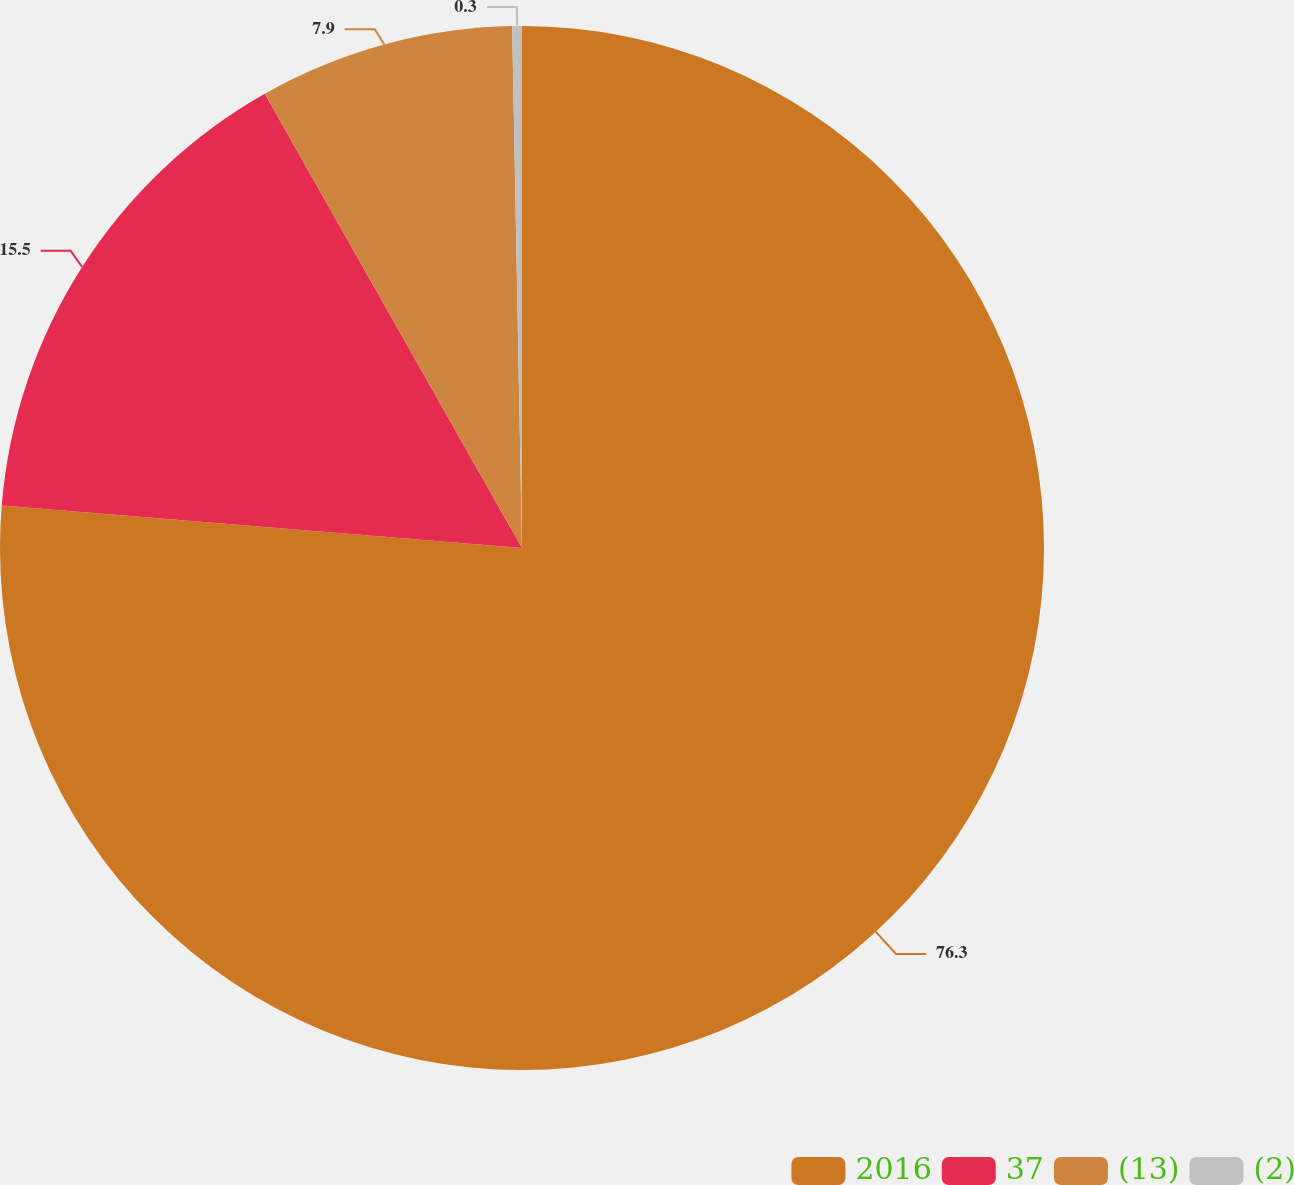Convert chart to OTSL. <chart><loc_0><loc_0><loc_500><loc_500><pie_chart><fcel>2016<fcel>37<fcel>(13)<fcel>(2)<nl><fcel>76.29%<fcel>15.5%<fcel>7.9%<fcel>0.3%<nl></chart> 